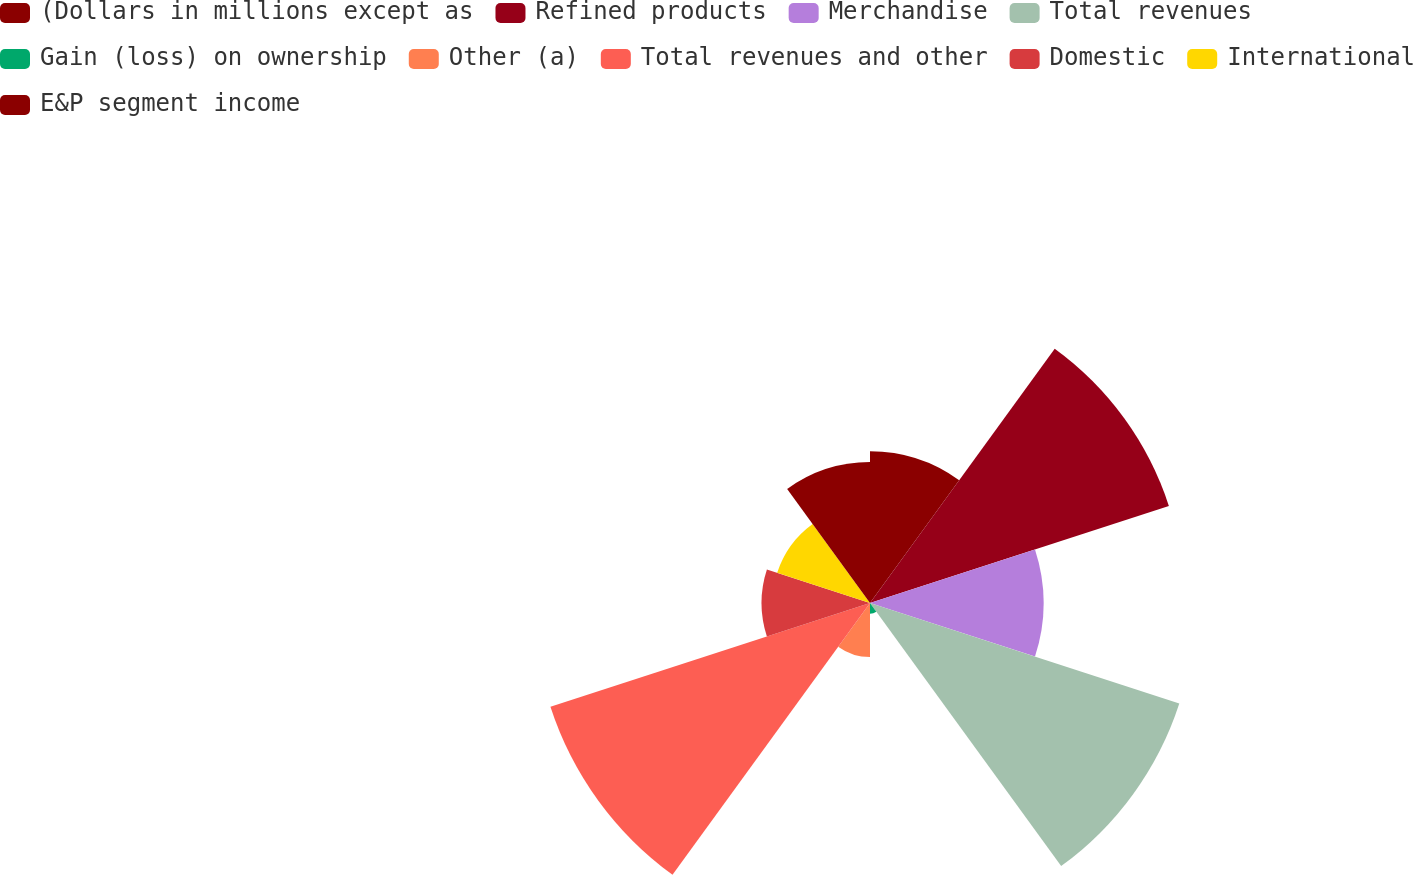Convert chart. <chart><loc_0><loc_0><loc_500><loc_500><pie_chart><fcel>(Dollars in millions except as<fcel>Refined products<fcel>Merchandise<fcel>Total revenues<fcel>Gain (loss) on ownership<fcel>Other (a)<fcel>Total revenues and other<fcel>Domestic<fcel>International<fcel>E&P segment income<nl><fcel>8.86%<fcel>18.35%<fcel>10.13%<fcel>18.99%<fcel>0.63%<fcel>3.16%<fcel>19.62%<fcel>6.33%<fcel>5.7%<fcel>8.23%<nl></chart> 